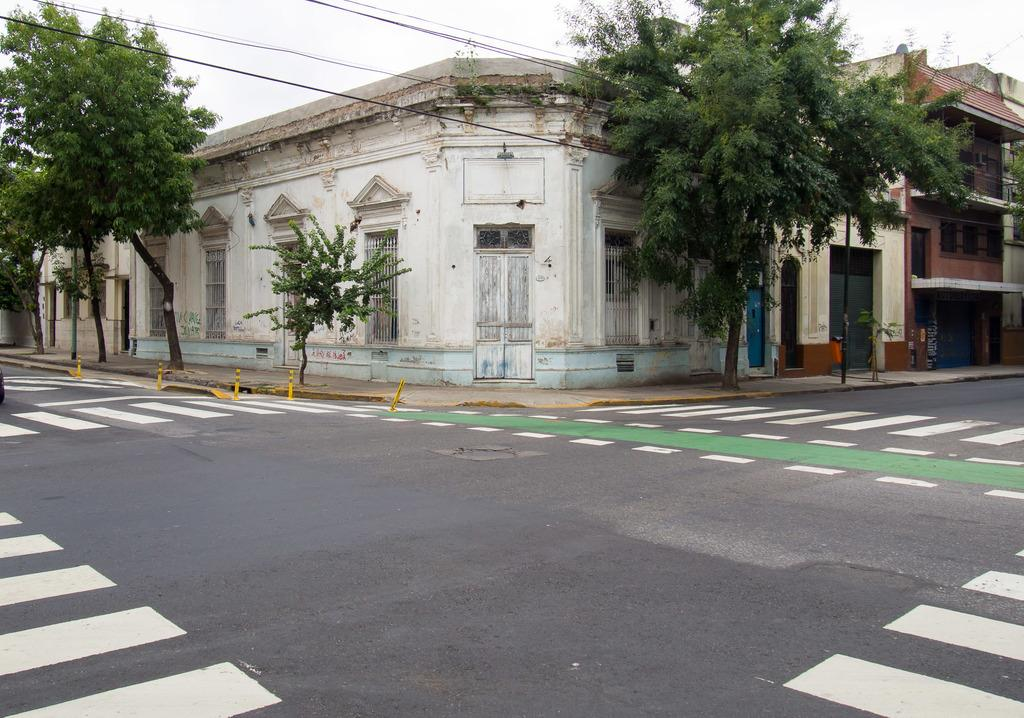What type of structures are present in the image? There are buildings in the image. What features can be seen on the buildings? The buildings have doors and windows. What other elements are present in the image besides the buildings? There are trees and a road in the image. What is visible at the top of the image? The sky is visible at the top of the image. What type of powder can be seen on the texture of the buildings in the image? There is no powder visible on the texture of the buildings in the image. How many girls are present in the image? There are no girls present in the image. 